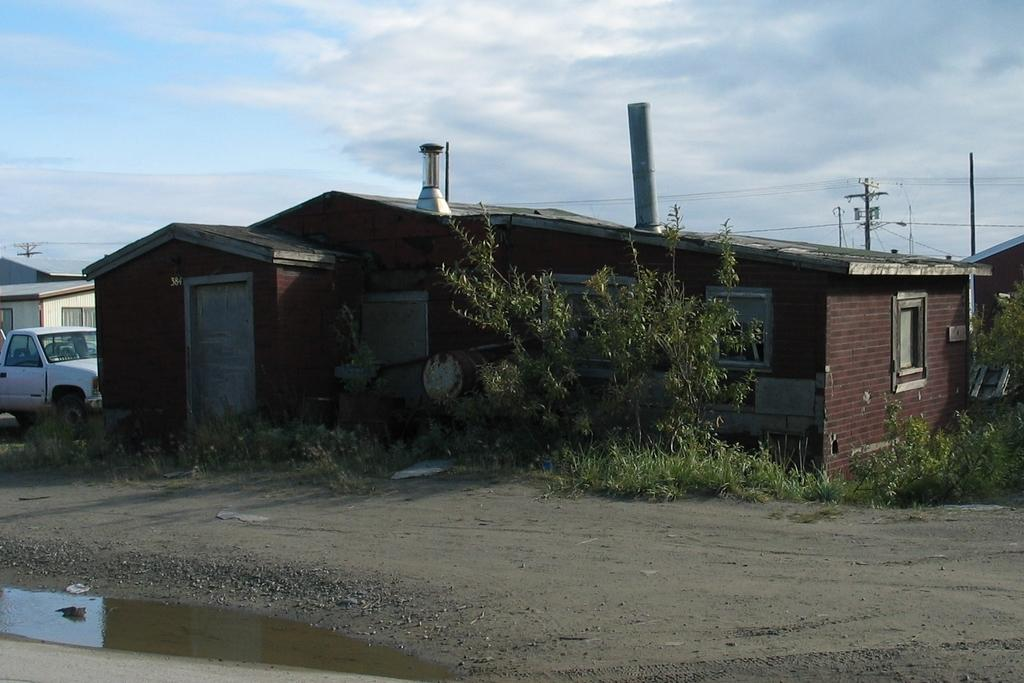What is in the foreground of the image? There is a ground in the foreground of the image. What type of vegetation is visible behind the ground? There is grass behind the ground. What can be seen behind the grass? There are trees behind the grass. What is located behind the trees? There are houses behind the trees. Where is the vehicle positioned in the image? The vehicle is on the left side of the image. Can you tell me how many hens are present on the farm in the image? There is no farm or hen present in the image. What type of peace symbol can be seen in the image? There is no peace symbol present in the image. 